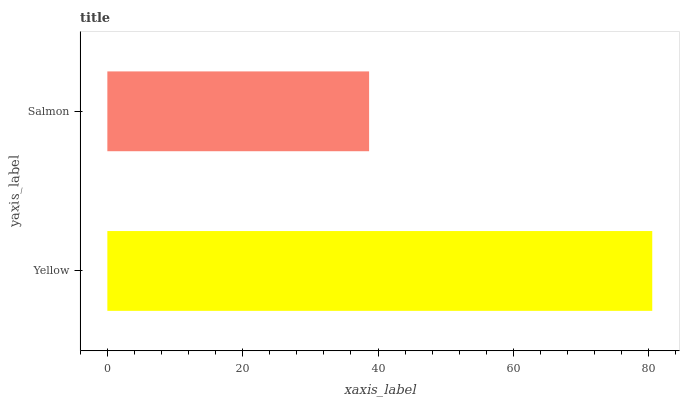Is Salmon the minimum?
Answer yes or no. Yes. Is Yellow the maximum?
Answer yes or no. Yes. Is Salmon the maximum?
Answer yes or no. No. Is Yellow greater than Salmon?
Answer yes or no. Yes. Is Salmon less than Yellow?
Answer yes or no. Yes. Is Salmon greater than Yellow?
Answer yes or no. No. Is Yellow less than Salmon?
Answer yes or no. No. Is Yellow the high median?
Answer yes or no. Yes. Is Salmon the low median?
Answer yes or no. Yes. Is Salmon the high median?
Answer yes or no. No. Is Yellow the low median?
Answer yes or no. No. 